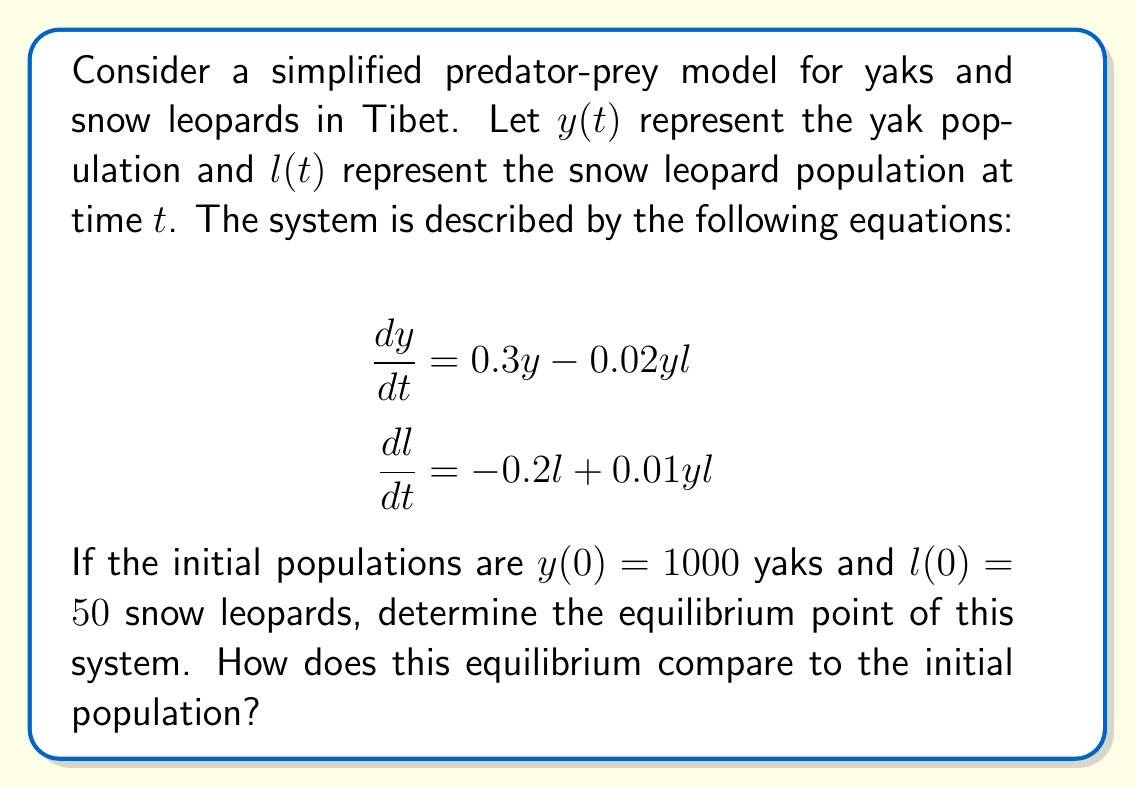What is the answer to this math problem? To find the equilibrium point, we need to set both equations equal to zero and solve for $y$ and $l$:

1) Set $\frac{dy}{dt} = 0$:
   $$0 = 0.3y - 0.02yl$$
   $$0.3y = 0.02yl$$
   $$15 = l$$ (Equation 1)

2) Set $\frac{dl}{dt} = 0$:
   $$0 = -0.2l + 0.01yl$$
   $$0.2l = 0.01yl$$
   $$20 = y$$ (Equation 2)

3) The equilibrium point is therefore $(y^*, l^*) = (20, 15)$.

4) Compare to initial conditions:
   - Initial yak population: 1000
   - Equilibrium yak population: 20
   - Initial snow leopard population: 50
   - Equilibrium snow leopard population: 15

The equilibrium populations are significantly lower than the initial populations for both species. The yak population decreases by 98%, while the snow leopard population decreases by 70%.

This model suggests that the initial populations are not sustainable in the long term, and both populations will decrease until they reach the equilibrium point.
Answer: Equilibrium point: $(20, 15)$. Significantly lower than initial populations. 